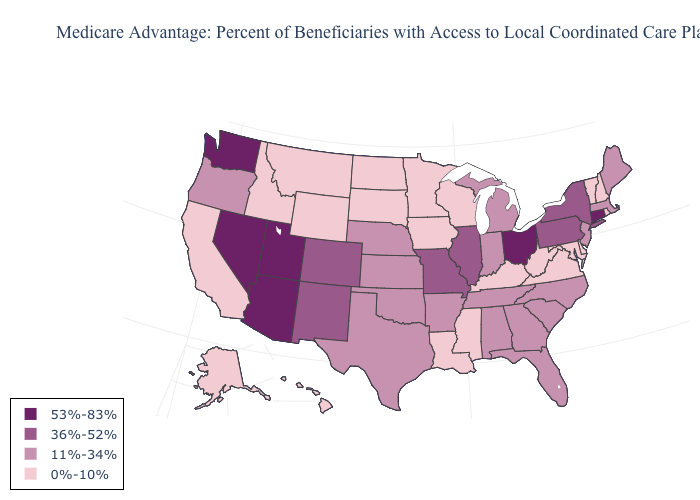Does New Jersey have a lower value than Arizona?
Short answer required. Yes. What is the value of Texas?
Keep it brief. 11%-34%. Does Massachusetts have a higher value than Maine?
Answer briefly. No. Among the states that border Illinois , does Kentucky have the highest value?
Quick response, please. No. Which states have the highest value in the USA?
Give a very brief answer. Arizona, Connecticut, Nevada, Ohio, Utah, Washington. Among the states that border Oregon , does Idaho have the lowest value?
Quick response, please. Yes. Does Washington have the lowest value in the USA?
Quick response, please. No. Name the states that have a value in the range 36%-52%?
Keep it brief. Colorado, Illinois, Missouri, New Mexico, New York, Pennsylvania. Name the states that have a value in the range 11%-34%?
Concise answer only. Alabama, Arkansas, Florida, Georgia, Indiana, Kansas, Massachusetts, Maine, Michigan, North Carolina, Nebraska, New Jersey, Oklahoma, Oregon, South Carolina, Tennessee, Texas. Does the map have missing data?
Write a very short answer. No. Which states have the highest value in the USA?
Concise answer only. Arizona, Connecticut, Nevada, Ohio, Utah, Washington. Is the legend a continuous bar?
Be succinct. No. Which states have the lowest value in the Northeast?
Short answer required. New Hampshire, Rhode Island, Vermont. Which states have the lowest value in the Northeast?
Answer briefly. New Hampshire, Rhode Island, Vermont. Name the states that have a value in the range 36%-52%?
Quick response, please. Colorado, Illinois, Missouri, New Mexico, New York, Pennsylvania. 